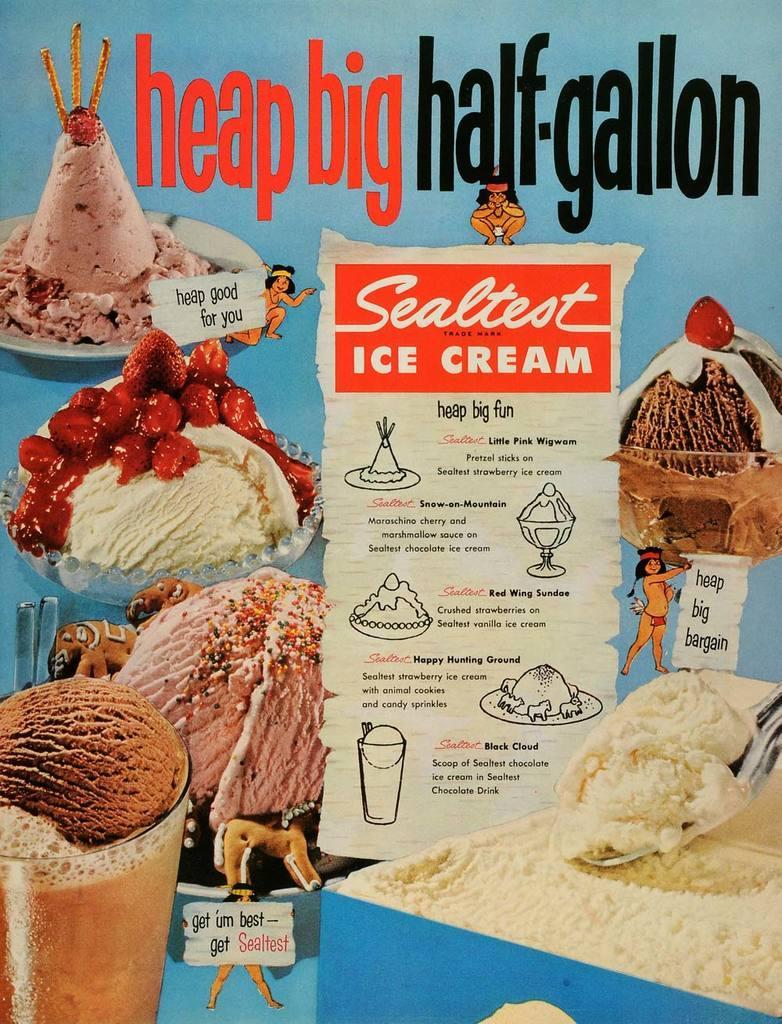Please provide a concise description of this image. In this image there is a poster with different flavors of ice creams and their description on it. 